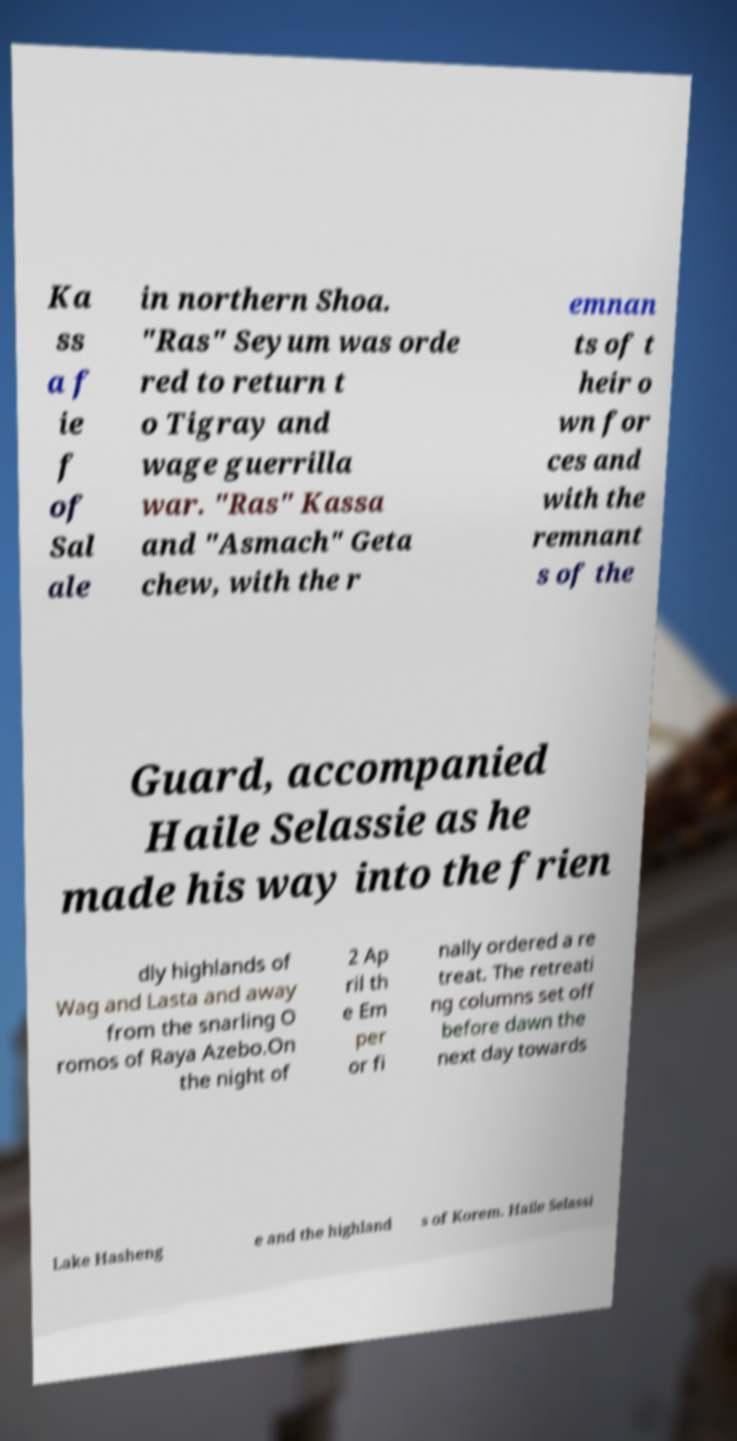There's text embedded in this image that I need extracted. Can you transcribe it verbatim? Ka ss a f ie f of Sal ale in northern Shoa. "Ras" Seyum was orde red to return t o Tigray and wage guerrilla war. "Ras" Kassa and "Asmach" Geta chew, with the r emnan ts of t heir o wn for ces and with the remnant s of the Guard, accompanied Haile Selassie as he made his way into the frien dly highlands of Wag and Lasta and away from the snarling O romos of Raya Azebo.On the night of 2 Ap ril th e Em per or fi nally ordered a re treat. The retreati ng columns set off before dawn the next day towards Lake Hasheng e and the highland s of Korem. Haile Selassi 